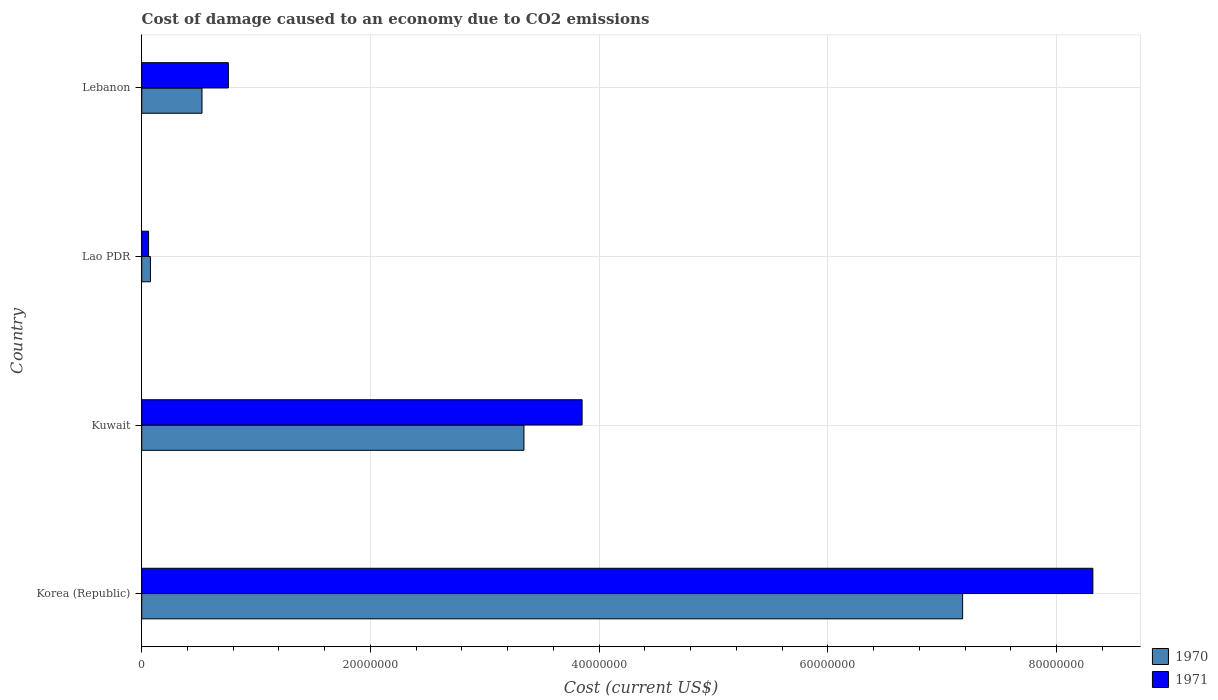How many groups of bars are there?
Ensure brevity in your answer.  4. Are the number of bars on each tick of the Y-axis equal?
Your answer should be compact. Yes. How many bars are there on the 2nd tick from the bottom?
Make the answer very short. 2. What is the cost of damage caused due to CO2 emissisons in 1971 in Korea (Republic)?
Your answer should be compact. 8.32e+07. Across all countries, what is the maximum cost of damage caused due to CO2 emissisons in 1970?
Provide a succinct answer. 7.18e+07. Across all countries, what is the minimum cost of damage caused due to CO2 emissisons in 1970?
Give a very brief answer. 7.64e+05. In which country was the cost of damage caused due to CO2 emissisons in 1970 maximum?
Provide a succinct answer. Korea (Republic). In which country was the cost of damage caused due to CO2 emissisons in 1970 minimum?
Give a very brief answer. Lao PDR. What is the total cost of damage caused due to CO2 emissisons in 1971 in the graph?
Give a very brief answer. 1.30e+08. What is the difference between the cost of damage caused due to CO2 emissisons in 1970 in Kuwait and that in Lao PDR?
Keep it short and to the point. 3.27e+07. What is the difference between the cost of damage caused due to CO2 emissisons in 1970 in Lebanon and the cost of damage caused due to CO2 emissisons in 1971 in Lao PDR?
Your response must be concise. 4.67e+06. What is the average cost of damage caused due to CO2 emissisons in 1971 per country?
Offer a terse response. 3.25e+07. What is the difference between the cost of damage caused due to CO2 emissisons in 1971 and cost of damage caused due to CO2 emissisons in 1970 in Korea (Republic)?
Offer a terse response. 1.14e+07. In how many countries, is the cost of damage caused due to CO2 emissisons in 1970 greater than 52000000 US$?
Make the answer very short. 1. What is the ratio of the cost of damage caused due to CO2 emissisons in 1971 in Korea (Republic) to that in Lao PDR?
Offer a terse response. 139. What is the difference between the highest and the second highest cost of damage caused due to CO2 emissisons in 1970?
Offer a terse response. 3.84e+07. What is the difference between the highest and the lowest cost of damage caused due to CO2 emissisons in 1971?
Offer a very short reply. 8.26e+07. In how many countries, is the cost of damage caused due to CO2 emissisons in 1970 greater than the average cost of damage caused due to CO2 emissisons in 1970 taken over all countries?
Offer a terse response. 2. What does the 1st bar from the bottom in Kuwait represents?
Offer a terse response. 1970. How many bars are there?
Offer a very short reply. 8. How many countries are there in the graph?
Give a very brief answer. 4. Does the graph contain any zero values?
Provide a short and direct response. No. Where does the legend appear in the graph?
Give a very brief answer. Bottom right. How many legend labels are there?
Your response must be concise. 2. How are the legend labels stacked?
Your answer should be very brief. Vertical. What is the title of the graph?
Your response must be concise. Cost of damage caused to an economy due to CO2 emissions. What is the label or title of the X-axis?
Provide a short and direct response. Cost (current US$). What is the Cost (current US$) in 1970 in Korea (Republic)?
Your response must be concise. 7.18e+07. What is the Cost (current US$) of 1971 in Korea (Republic)?
Give a very brief answer. 8.32e+07. What is the Cost (current US$) in 1970 in Kuwait?
Make the answer very short. 3.34e+07. What is the Cost (current US$) of 1971 in Kuwait?
Offer a very short reply. 3.85e+07. What is the Cost (current US$) in 1970 in Lao PDR?
Offer a very short reply. 7.64e+05. What is the Cost (current US$) in 1971 in Lao PDR?
Ensure brevity in your answer.  5.98e+05. What is the Cost (current US$) of 1970 in Lebanon?
Your answer should be compact. 5.27e+06. What is the Cost (current US$) of 1971 in Lebanon?
Keep it short and to the point. 7.58e+06. Across all countries, what is the maximum Cost (current US$) of 1970?
Give a very brief answer. 7.18e+07. Across all countries, what is the maximum Cost (current US$) of 1971?
Ensure brevity in your answer.  8.32e+07. Across all countries, what is the minimum Cost (current US$) of 1970?
Ensure brevity in your answer.  7.64e+05. Across all countries, what is the minimum Cost (current US$) in 1971?
Your answer should be compact. 5.98e+05. What is the total Cost (current US$) in 1970 in the graph?
Ensure brevity in your answer.  1.11e+08. What is the total Cost (current US$) in 1971 in the graph?
Make the answer very short. 1.30e+08. What is the difference between the Cost (current US$) of 1970 in Korea (Republic) and that in Kuwait?
Provide a succinct answer. 3.84e+07. What is the difference between the Cost (current US$) of 1971 in Korea (Republic) and that in Kuwait?
Keep it short and to the point. 4.47e+07. What is the difference between the Cost (current US$) in 1970 in Korea (Republic) and that in Lao PDR?
Offer a terse response. 7.10e+07. What is the difference between the Cost (current US$) of 1971 in Korea (Republic) and that in Lao PDR?
Provide a succinct answer. 8.26e+07. What is the difference between the Cost (current US$) in 1970 in Korea (Republic) and that in Lebanon?
Keep it short and to the point. 6.65e+07. What is the difference between the Cost (current US$) in 1971 in Korea (Republic) and that in Lebanon?
Keep it short and to the point. 7.56e+07. What is the difference between the Cost (current US$) in 1970 in Kuwait and that in Lao PDR?
Your answer should be compact. 3.27e+07. What is the difference between the Cost (current US$) in 1971 in Kuwait and that in Lao PDR?
Offer a terse response. 3.79e+07. What is the difference between the Cost (current US$) in 1970 in Kuwait and that in Lebanon?
Your answer should be very brief. 2.82e+07. What is the difference between the Cost (current US$) of 1971 in Kuwait and that in Lebanon?
Your answer should be compact. 3.09e+07. What is the difference between the Cost (current US$) in 1970 in Lao PDR and that in Lebanon?
Keep it short and to the point. -4.51e+06. What is the difference between the Cost (current US$) in 1971 in Lao PDR and that in Lebanon?
Offer a very short reply. -6.98e+06. What is the difference between the Cost (current US$) in 1970 in Korea (Republic) and the Cost (current US$) in 1971 in Kuwait?
Your answer should be compact. 3.33e+07. What is the difference between the Cost (current US$) of 1970 in Korea (Republic) and the Cost (current US$) of 1971 in Lao PDR?
Make the answer very short. 7.12e+07. What is the difference between the Cost (current US$) in 1970 in Korea (Republic) and the Cost (current US$) in 1971 in Lebanon?
Provide a succinct answer. 6.42e+07. What is the difference between the Cost (current US$) in 1970 in Kuwait and the Cost (current US$) in 1971 in Lao PDR?
Make the answer very short. 3.28e+07. What is the difference between the Cost (current US$) of 1970 in Kuwait and the Cost (current US$) of 1971 in Lebanon?
Offer a very short reply. 2.58e+07. What is the difference between the Cost (current US$) of 1970 in Lao PDR and the Cost (current US$) of 1971 in Lebanon?
Ensure brevity in your answer.  -6.81e+06. What is the average Cost (current US$) of 1970 per country?
Provide a short and direct response. 2.78e+07. What is the average Cost (current US$) of 1971 per country?
Provide a succinct answer. 3.25e+07. What is the difference between the Cost (current US$) of 1970 and Cost (current US$) of 1971 in Korea (Republic)?
Offer a terse response. -1.14e+07. What is the difference between the Cost (current US$) in 1970 and Cost (current US$) in 1971 in Kuwait?
Your answer should be compact. -5.09e+06. What is the difference between the Cost (current US$) in 1970 and Cost (current US$) in 1971 in Lao PDR?
Your answer should be compact. 1.65e+05. What is the difference between the Cost (current US$) of 1970 and Cost (current US$) of 1971 in Lebanon?
Your answer should be compact. -2.30e+06. What is the ratio of the Cost (current US$) of 1970 in Korea (Republic) to that in Kuwait?
Your answer should be very brief. 2.15. What is the ratio of the Cost (current US$) of 1971 in Korea (Republic) to that in Kuwait?
Offer a very short reply. 2.16. What is the ratio of the Cost (current US$) in 1970 in Korea (Republic) to that in Lao PDR?
Offer a very short reply. 94.02. What is the ratio of the Cost (current US$) of 1971 in Korea (Republic) to that in Lao PDR?
Provide a short and direct response. 139. What is the ratio of the Cost (current US$) of 1970 in Korea (Republic) to that in Lebanon?
Provide a succinct answer. 13.62. What is the ratio of the Cost (current US$) of 1971 in Korea (Republic) to that in Lebanon?
Offer a very short reply. 10.98. What is the ratio of the Cost (current US$) in 1970 in Kuwait to that in Lao PDR?
Provide a succinct answer. 43.78. What is the ratio of the Cost (current US$) of 1971 in Kuwait to that in Lao PDR?
Ensure brevity in your answer.  64.36. What is the ratio of the Cost (current US$) in 1970 in Kuwait to that in Lebanon?
Your answer should be compact. 6.34. What is the ratio of the Cost (current US$) of 1971 in Kuwait to that in Lebanon?
Ensure brevity in your answer.  5.08. What is the ratio of the Cost (current US$) in 1970 in Lao PDR to that in Lebanon?
Offer a terse response. 0.14. What is the ratio of the Cost (current US$) in 1971 in Lao PDR to that in Lebanon?
Provide a succinct answer. 0.08. What is the difference between the highest and the second highest Cost (current US$) of 1970?
Provide a short and direct response. 3.84e+07. What is the difference between the highest and the second highest Cost (current US$) in 1971?
Your response must be concise. 4.47e+07. What is the difference between the highest and the lowest Cost (current US$) of 1970?
Ensure brevity in your answer.  7.10e+07. What is the difference between the highest and the lowest Cost (current US$) in 1971?
Provide a succinct answer. 8.26e+07. 